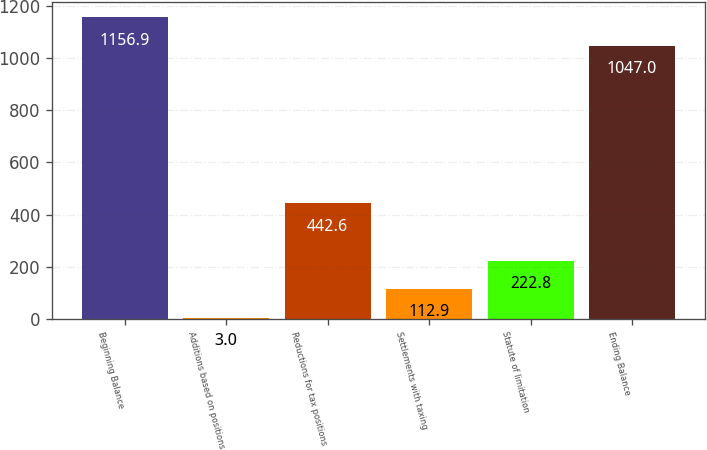Convert chart. <chart><loc_0><loc_0><loc_500><loc_500><bar_chart><fcel>Beginning Balance<fcel>Additions based on positions<fcel>Reductions for tax positions<fcel>Settlements with taxing<fcel>Statute of limitation<fcel>Ending Balance<nl><fcel>1156.9<fcel>3<fcel>442.6<fcel>112.9<fcel>222.8<fcel>1047<nl></chart> 